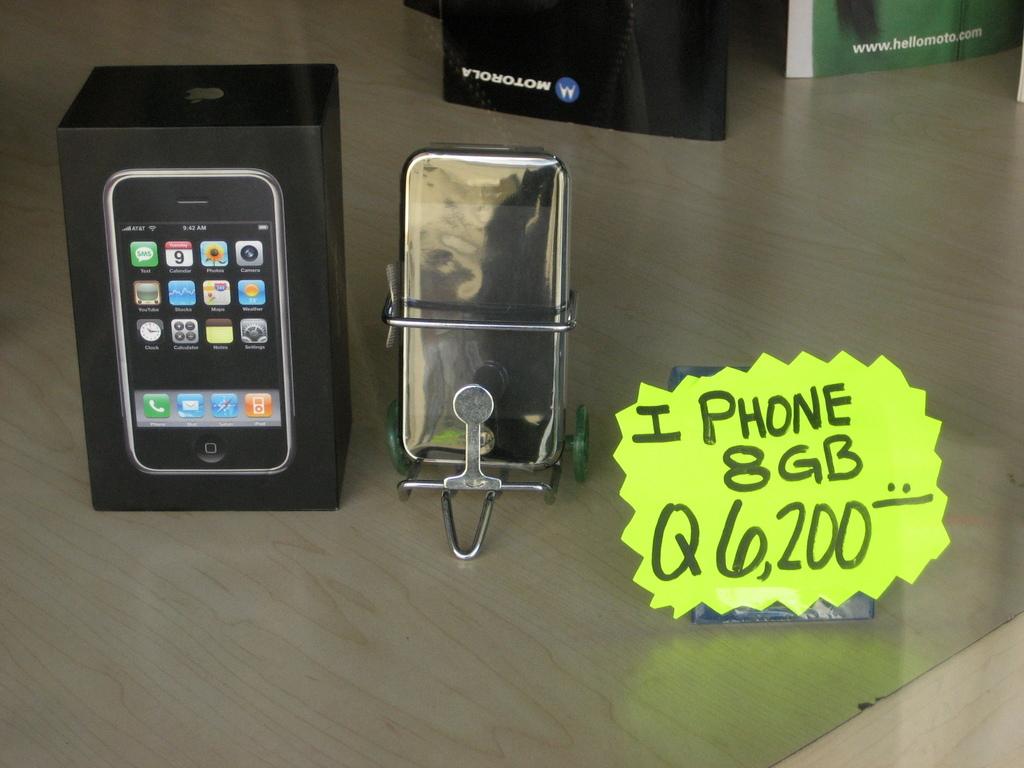How many gb's does the phone have?
Your answer should be very brief. 8. How many gb is the iphone being sold?
Provide a short and direct response. 8. 